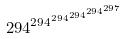<formula> <loc_0><loc_0><loc_500><loc_500>2 9 4 ^ { 2 9 4 ^ { 2 9 4 ^ { 2 9 4 ^ { 2 9 4 ^ { 2 9 7 } } } } }</formula> 